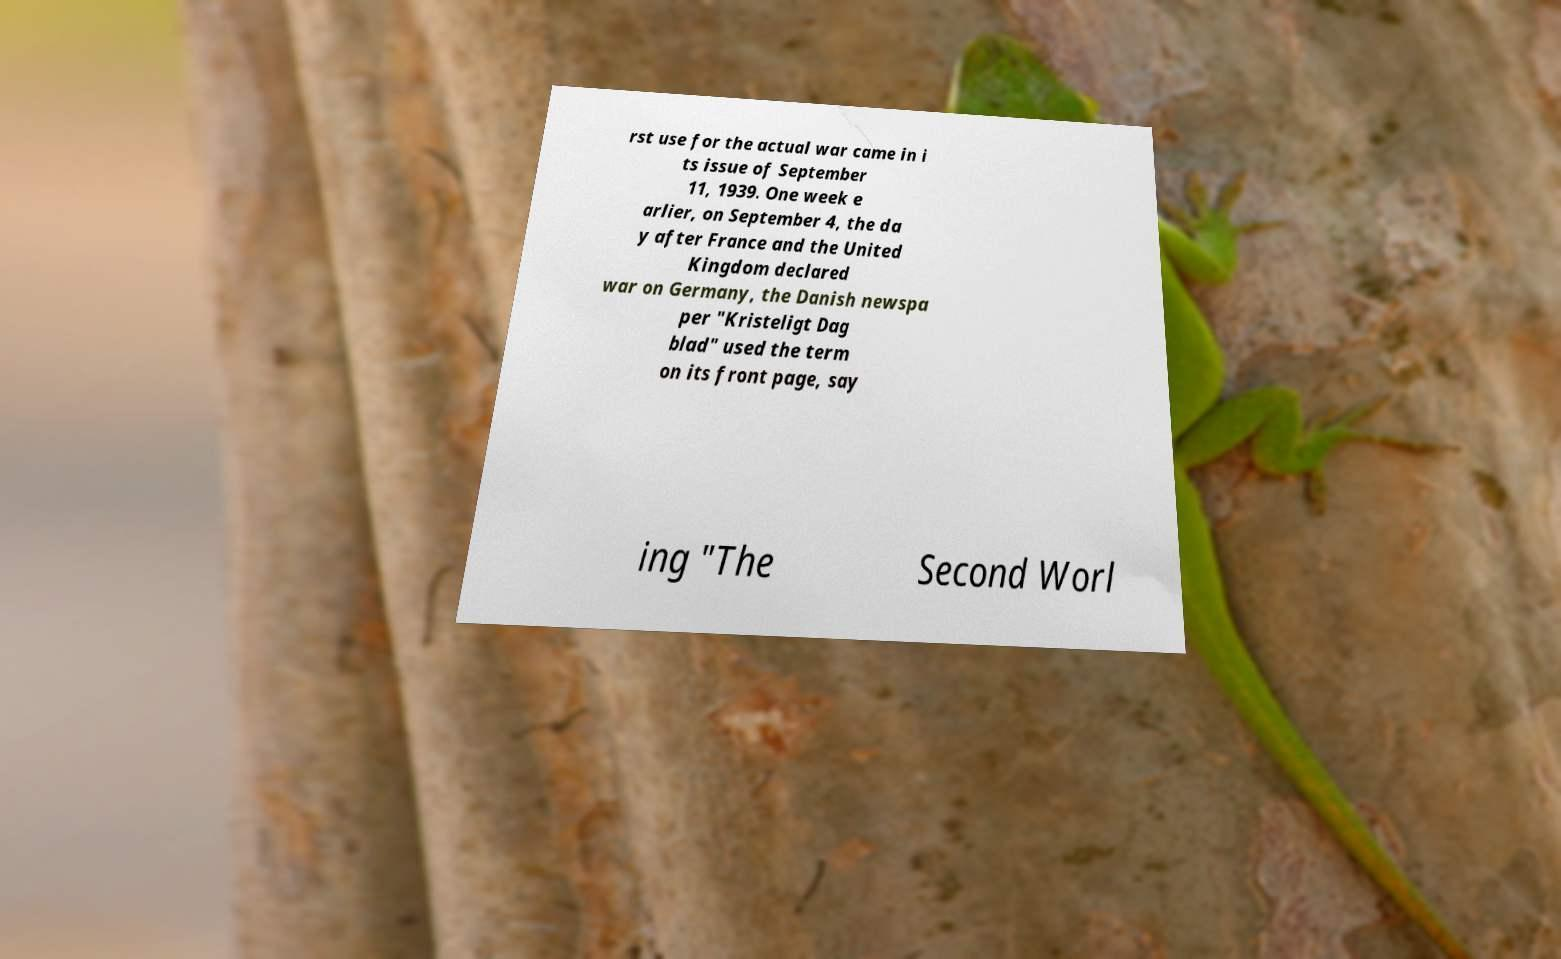Can you read and provide the text displayed in the image?This photo seems to have some interesting text. Can you extract and type it out for me? rst use for the actual war came in i ts issue of September 11, 1939. One week e arlier, on September 4, the da y after France and the United Kingdom declared war on Germany, the Danish newspa per "Kristeligt Dag blad" used the term on its front page, say ing "The Second Worl 